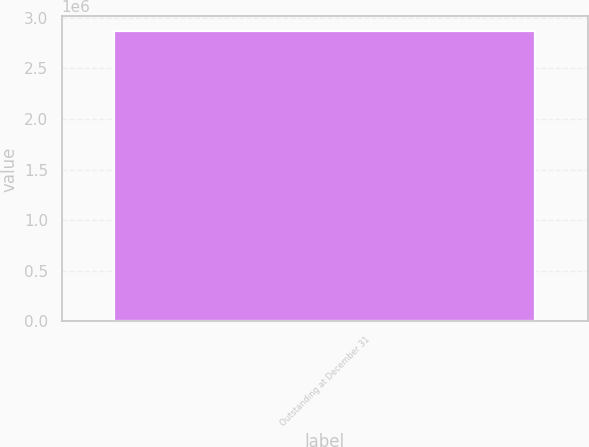Convert chart to OTSL. <chart><loc_0><loc_0><loc_500><loc_500><bar_chart><fcel>Outstanding at December 31<nl><fcel>2.87194e+06<nl></chart> 